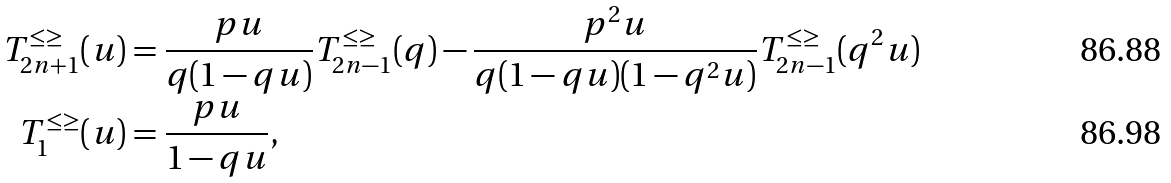<formula> <loc_0><loc_0><loc_500><loc_500>T ^ { \leq \geq } _ { 2 n + 1 } ( u ) & = \frac { p u } { q ( 1 - q u ) } T ^ { \leq \geq } _ { 2 n - 1 } ( q ) - \frac { p ^ { 2 } u } { q ( 1 - q u ) ( 1 - q ^ { 2 } u ) } T ^ { \leq \geq } _ { 2 n - 1 } ( q ^ { 2 } u ) \\ T ^ { \leq \geq } _ { 1 } ( u ) & = \frac { p u } { 1 - q u } ,</formula> 